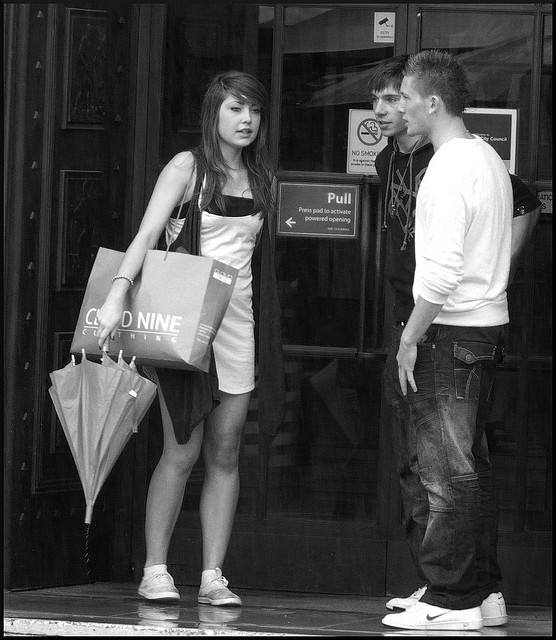Describe the objects in this image and their specific colors. I can see people in black, white, gray, and darkgray tones, people in black, gray, darkgray, and lightgray tones, people in black, gray, darkgray, and lightgray tones, handbag in black, lightgray, darkgray, and gray tones, and umbrella in black, darkgray, gray, and lightgray tones in this image. 